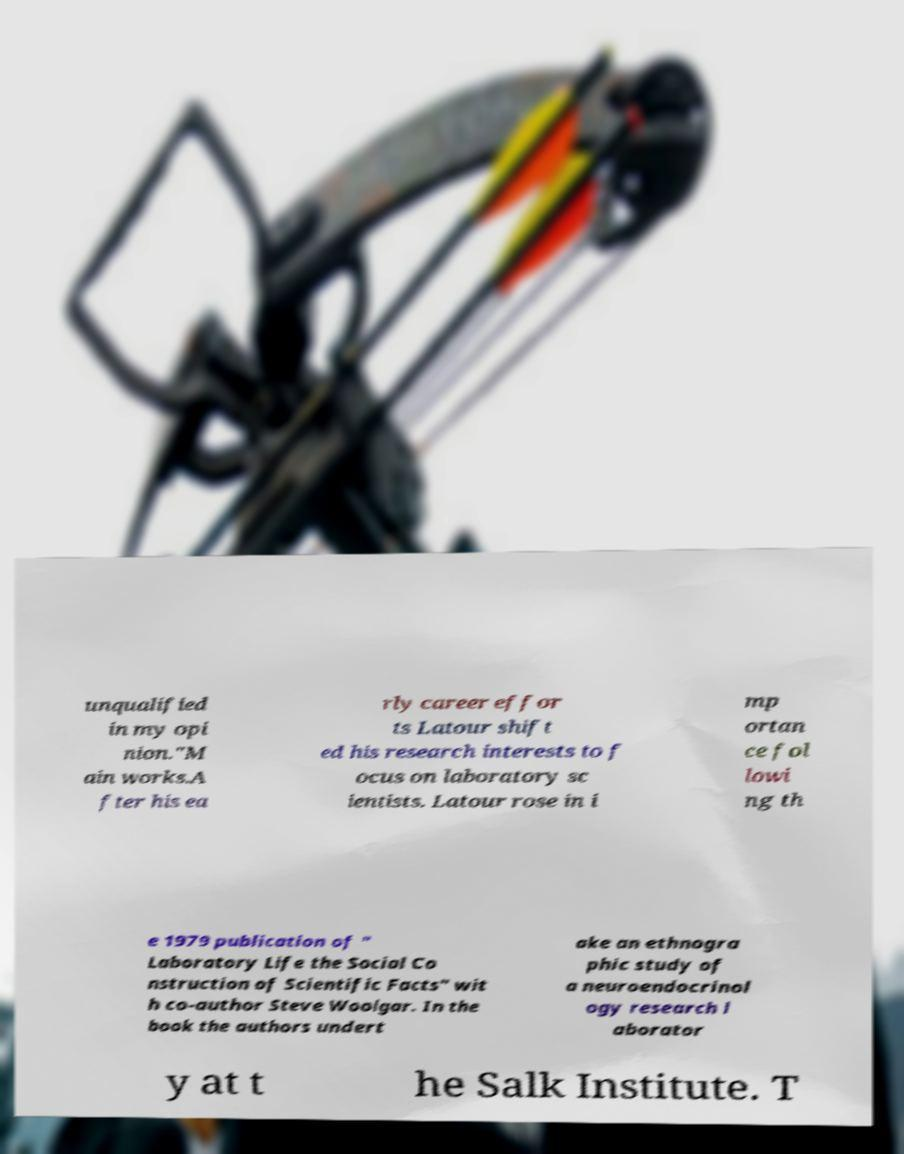Please read and relay the text visible in this image. What does it say? unqualified in my opi nion."M ain works.A fter his ea rly career effor ts Latour shift ed his research interests to f ocus on laboratory sc ientists. Latour rose in i mp ortan ce fol lowi ng th e 1979 publication of " Laboratory Life the Social Co nstruction of Scientific Facts" wit h co-author Steve Woolgar. In the book the authors undert ake an ethnogra phic study of a neuroendocrinol ogy research l aborator y at t he Salk Institute. T 